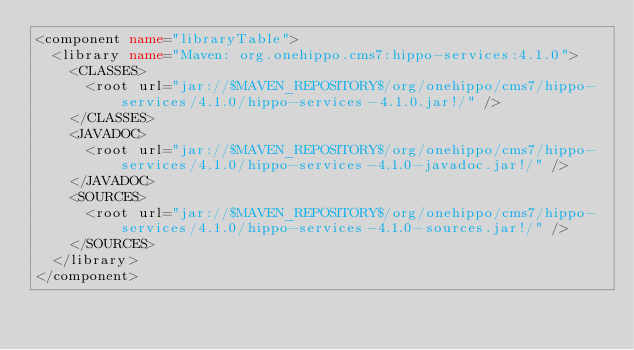<code> <loc_0><loc_0><loc_500><loc_500><_XML_><component name="libraryTable">
  <library name="Maven: org.onehippo.cms7:hippo-services:4.1.0">
    <CLASSES>
      <root url="jar://$MAVEN_REPOSITORY$/org/onehippo/cms7/hippo-services/4.1.0/hippo-services-4.1.0.jar!/" />
    </CLASSES>
    <JAVADOC>
      <root url="jar://$MAVEN_REPOSITORY$/org/onehippo/cms7/hippo-services/4.1.0/hippo-services-4.1.0-javadoc.jar!/" />
    </JAVADOC>
    <SOURCES>
      <root url="jar://$MAVEN_REPOSITORY$/org/onehippo/cms7/hippo-services/4.1.0/hippo-services-4.1.0-sources.jar!/" />
    </SOURCES>
  </library>
</component></code> 